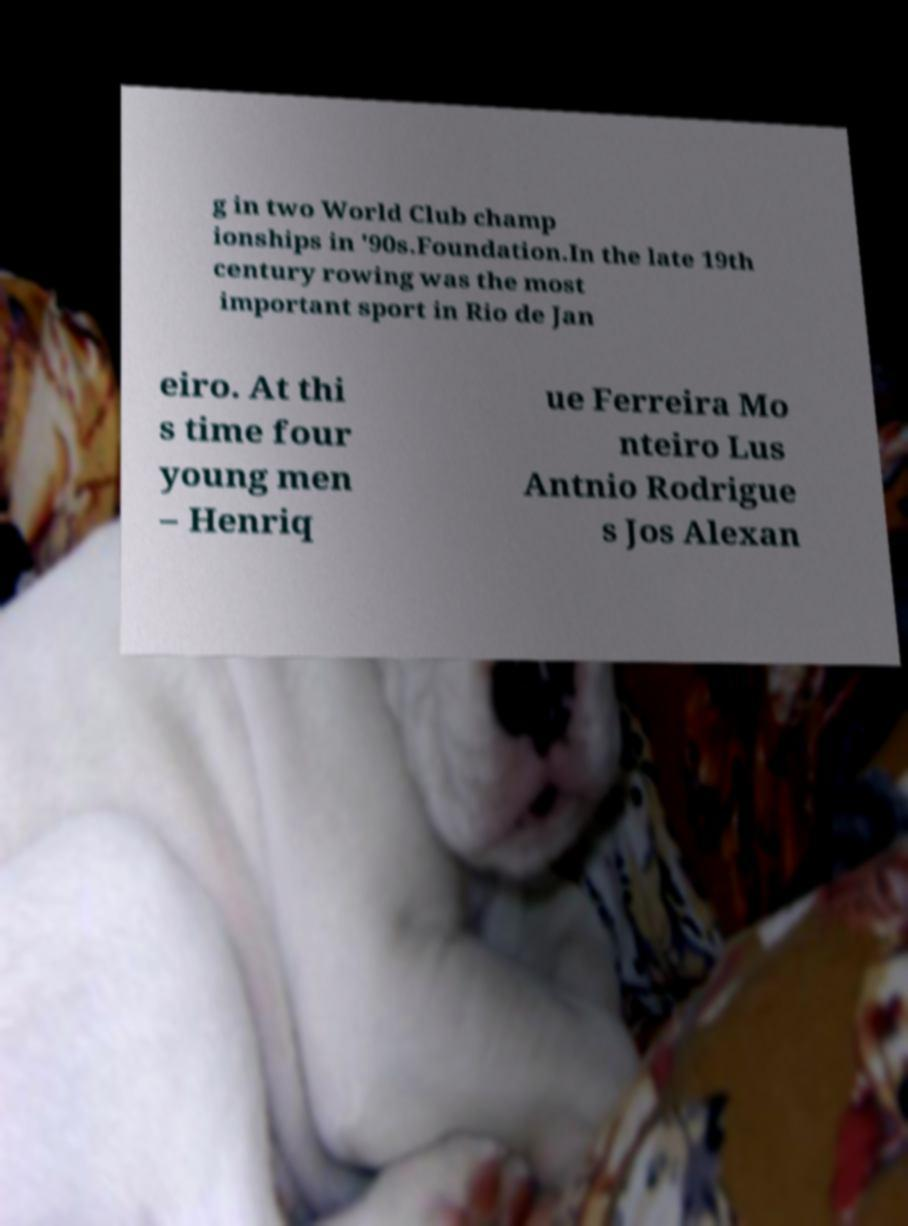Could you extract and type out the text from this image? g in two World Club champ ionships in '90s.Foundation.In the late 19th century rowing was the most important sport in Rio de Jan eiro. At thi s time four young men – Henriq ue Ferreira Mo nteiro Lus Antnio Rodrigue s Jos Alexan 